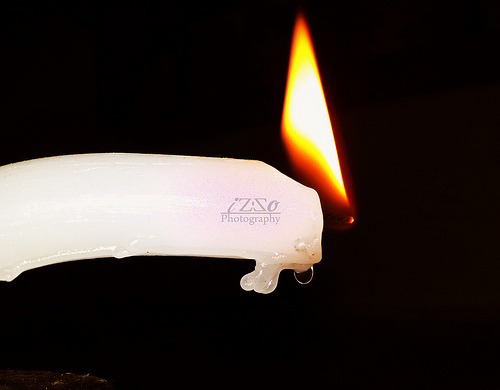<image>
Is there a fire on the candle? Yes. Looking at the image, I can see the fire is positioned on top of the candle, with the candle providing support. 